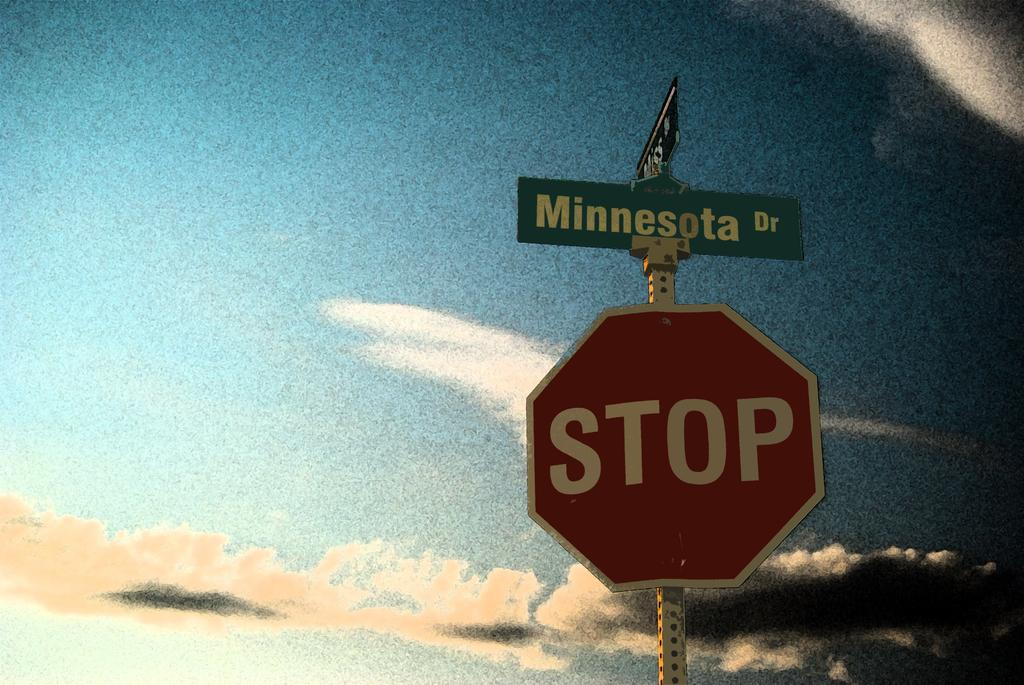<image>
Create a compact narrative representing the image presented. a stop sign that is outside with the word Minnesota above it 